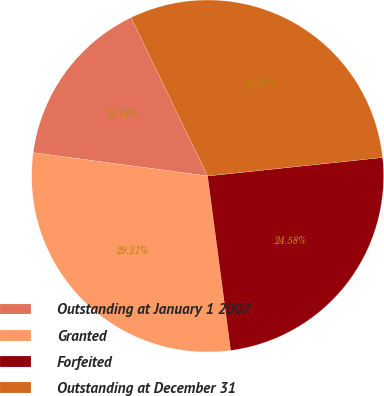Convert chart. <chart><loc_0><loc_0><loc_500><loc_500><pie_chart><fcel>Outstanding at January 1 2007<fcel>Granted<fcel>Forfeited<fcel>Outstanding at December 31<nl><fcel>15.72%<fcel>29.21%<fcel>24.58%<fcel>30.49%<nl></chart> 